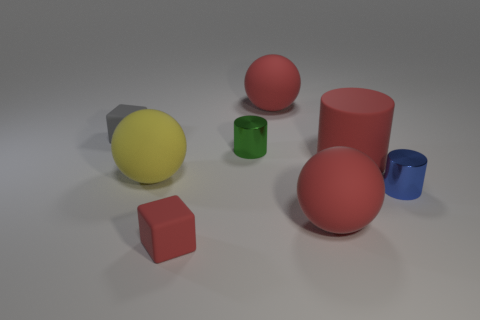Subtract all red rubber spheres. How many spheres are left? 1 Subtract all gray cubes. How many cubes are left? 1 Subtract all cubes. How many objects are left? 6 Subtract all cyan cubes. How many yellow balls are left? 1 Add 1 large red shiny objects. How many objects exist? 9 Add 5 large red rubber cylinders. How many large red rubber cylinders exist? 6 Subtract 0 gray spheres. How many objects are left? 8 Subtract 2 spheres. How many spheres are left? 1 Subtract all purple cubes. Subtract all red balls. How many cubes are left? 2 Subtract all small blue metallic things. Subtract all big red matte cylinders. How many objects are left? 6 